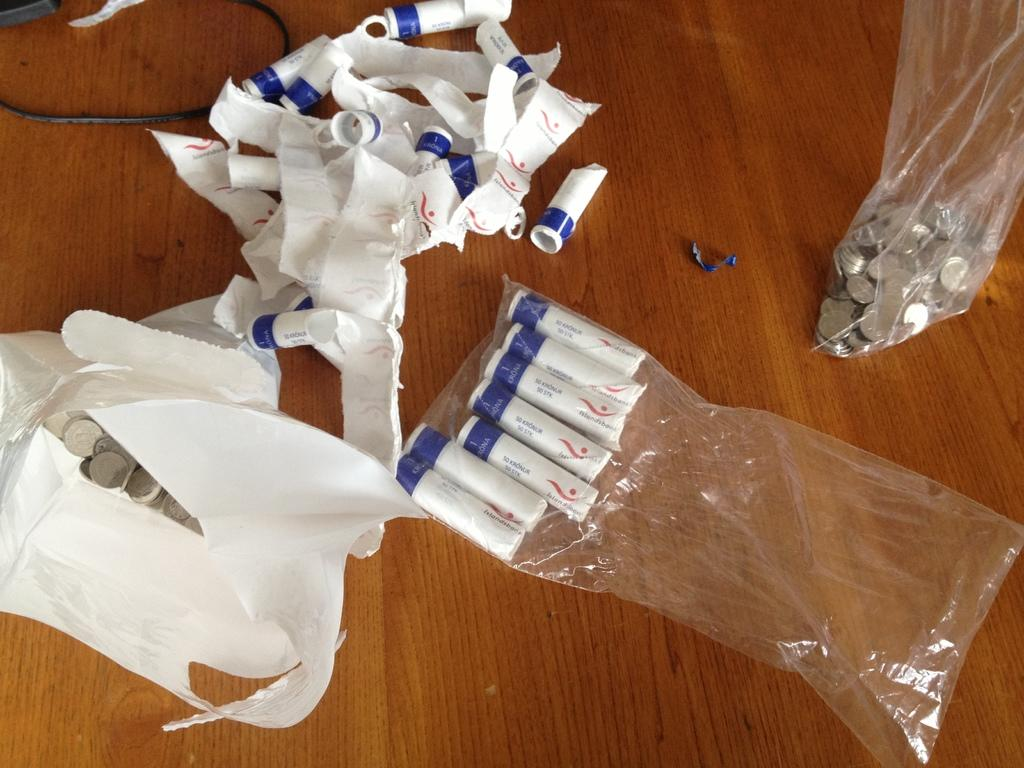What color are the objects in the image? The objects in the image are white. What type of items can be seen on the wooden surface? Coins are present in the image. What is the material of the surface where the objects and coins are placed? The objects and coins are on a wooden surface. What type of cup is being used to play the game with mom in the image? There is no cup or game with mom present in the image. 